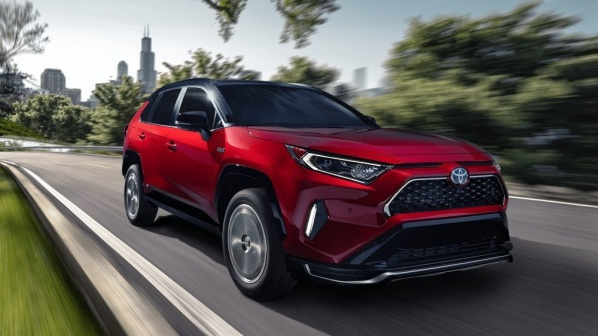What technical specs might this car have given its appearance? Given the modern and sporty appearance of this Toyota RAV4, it is likely equipped with a powerful yet efficient engine, possibly a 2.5L 4-cylinder engine. It may feature hybrid technology for improved fuel efficiency. The SUV is likely loaded with advanced safety and driving assistance features such as adaptive cruise control, lane departure warning, and blind-spot monitoring. Additionally, the interior might include high-tech amenities like a touchscreen infotainment system, premium audio, and smartphone integration. 